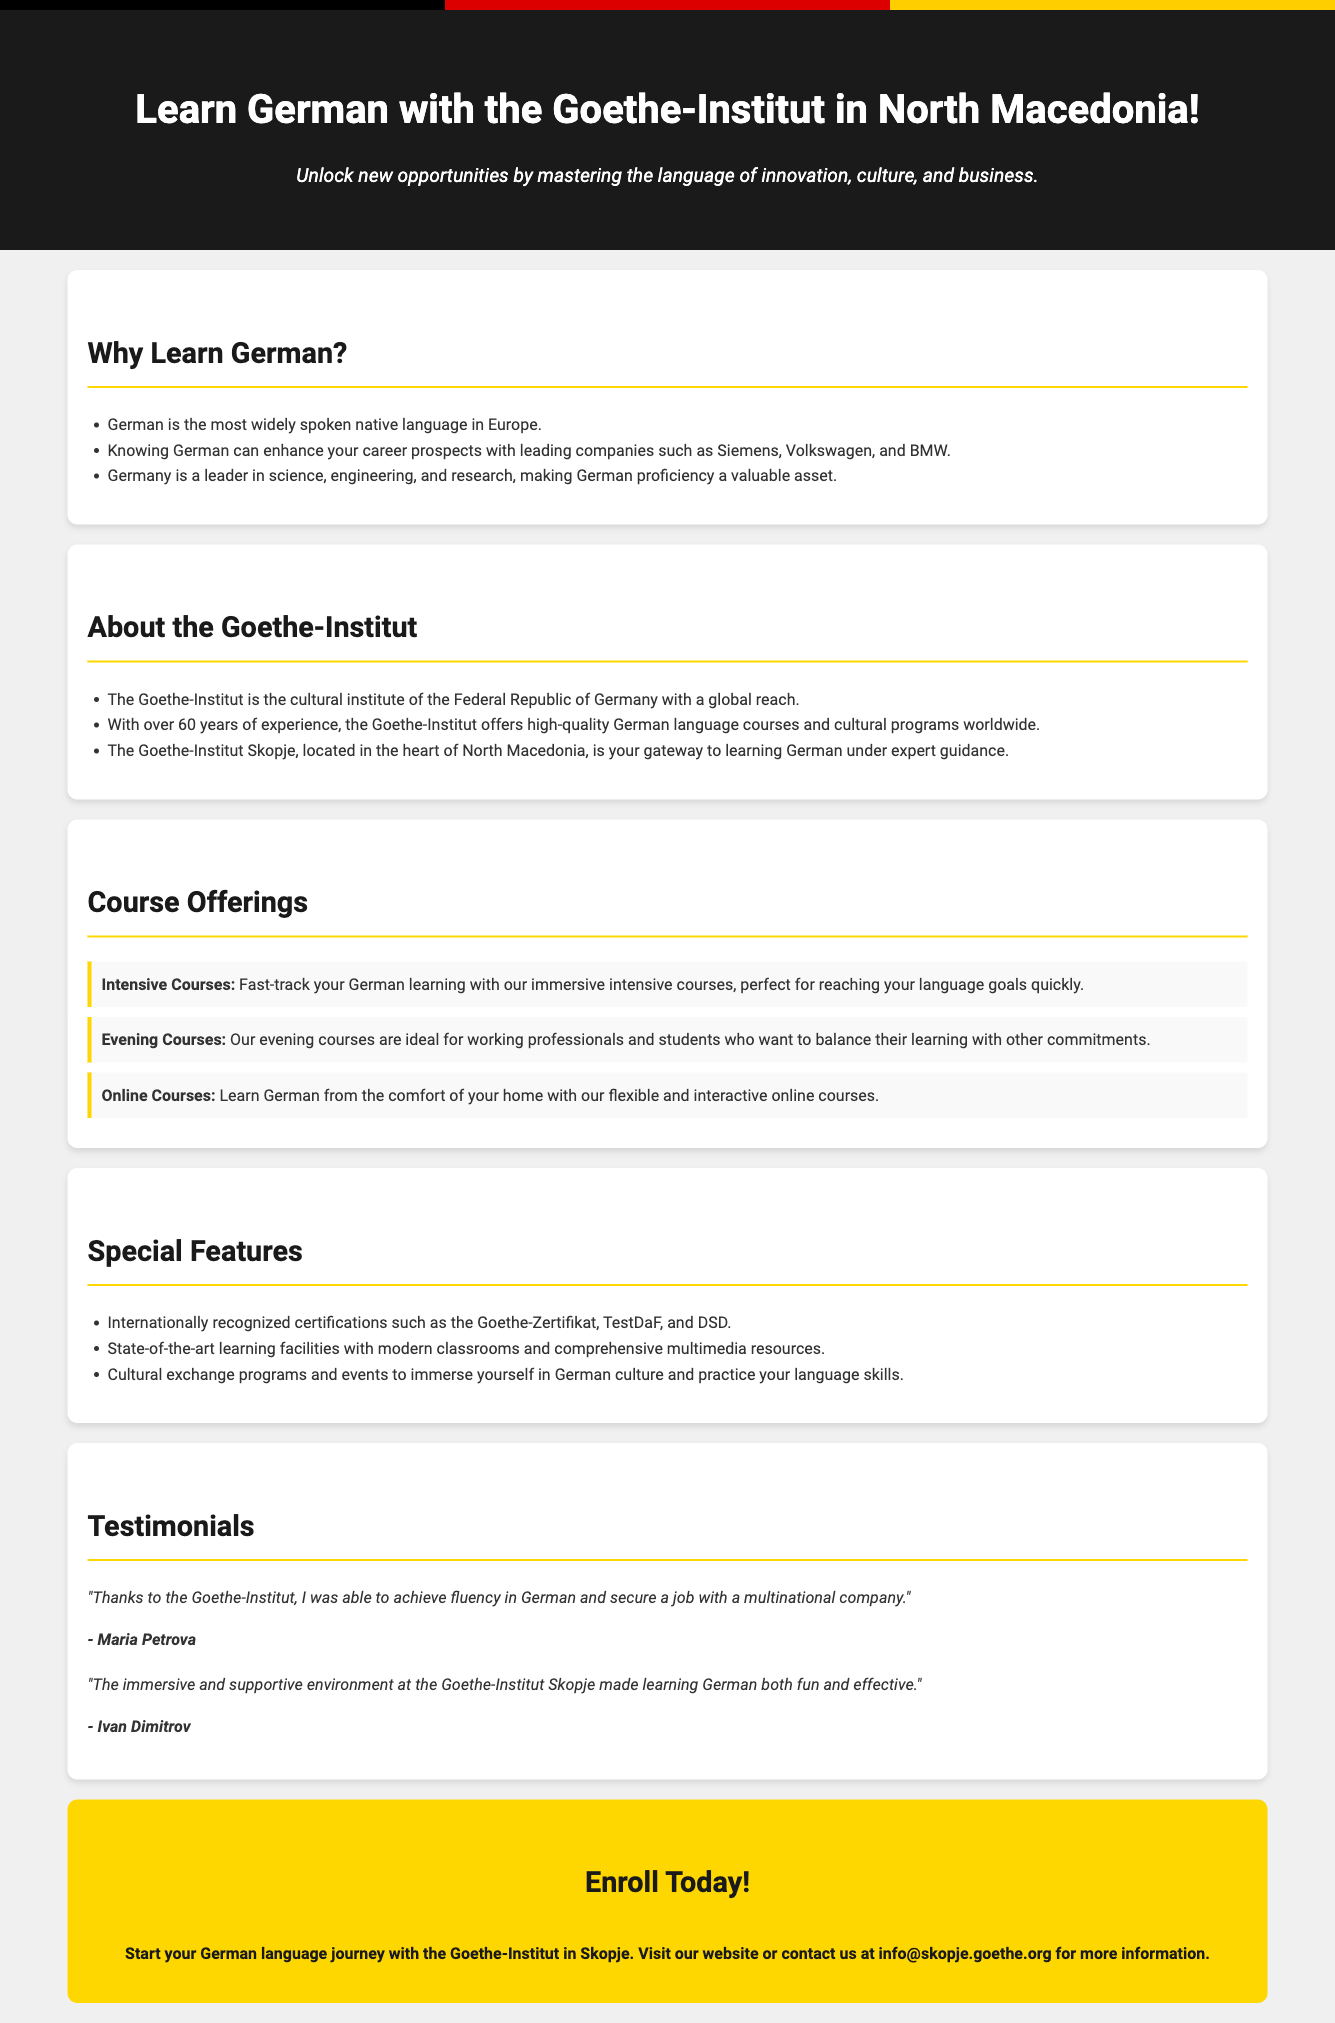What is the name of the institute offering the courses? The name of the institute mentioned in the document is "Goethe-Institut."
Answer: Goethe-Institut What type of courses are available online? The document mentions that you can learn German from home through "Online Courses."
Answer: Online Courses What is the primary language being taught? The promotional advertisement is focused on teaching the German language.
Answer: German How many years of experience does the Goethe-Institut have? The document states that the Goethe-Institut has over 60 years of experience.
Answer: 60 years Which certification is internationally recognized as per the document? The document lists "Goethe-Zertifikat" as one of the internationally recognized certifications.
Answer: Goethe-Zertifikat What is an ideal group for evening courses? The evening courses are described as ideal for "working professionals and students."
Answer: working professionals and students What feature enhances career prospects according to the document? Knowing German can enhance career prospects with leading companies.
Answer: Career prospects Who provided a testimonial about achieving fluency? The testimonial regarding achieving fluency in German is given by "Maria Petrova."
Answer: Maria Petrova What is the color of the "Enroll Today!" call-to-action section? The call-to-action section is highlighted in "gold."
Answer: gold 